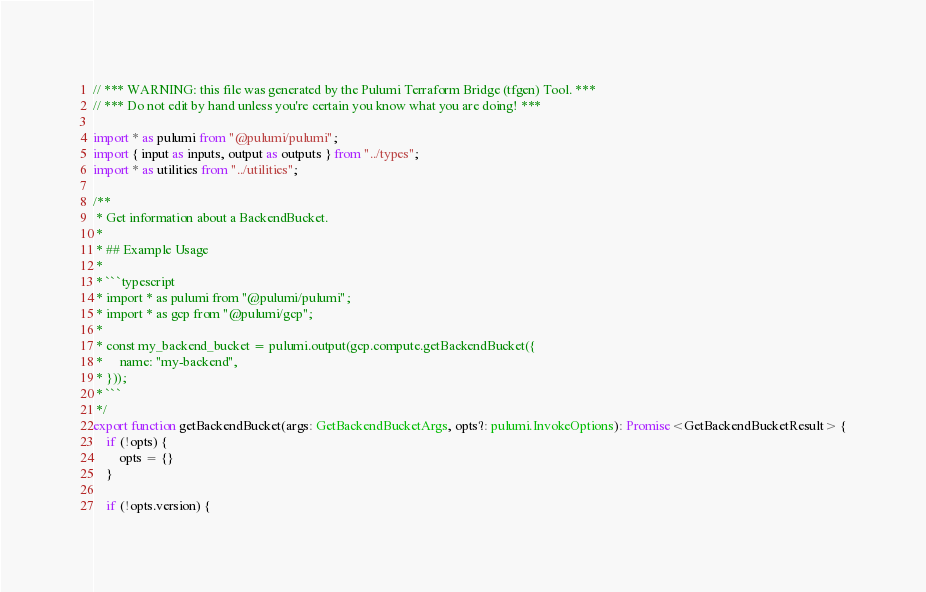Convert code to text. <code><loc_0><loc_0><loc_500><loc_500><_TypeScript_>// *** WARNING: this file was generated by the Pulumi Terraform Bridge (tfgen) Tool. ***
// *** Do not edit by hand unless you're certain you know what you are doing! ***

import * as pulumi from "@pulumi/pulumi";
import { input as inputs, output as outputs } from "../types";
import * as utilities from "../utilities";

/**
 * Get information about a BackendBucket.
 *
 * ## Example Usage
 *
 * ```typescript
 * import * as pulumi from "@pulumi/pulumi";
 * import * as gcp from "@pulumi/gcp";
 *
 * const my_backend_bucket = pulumi.output(gcp.compute.getBackendBucket({
 *     name: "my-backend",
 * }));
 * ```
 */
export function getBackendBucket(args: GetBackendBucketArgs, opts?: pulumi.InvokeOptions): Promise<GetBackendBucketResult> {
    if (!opts) {
        opts = {}
    }

    if (!opts.version) {</code> 